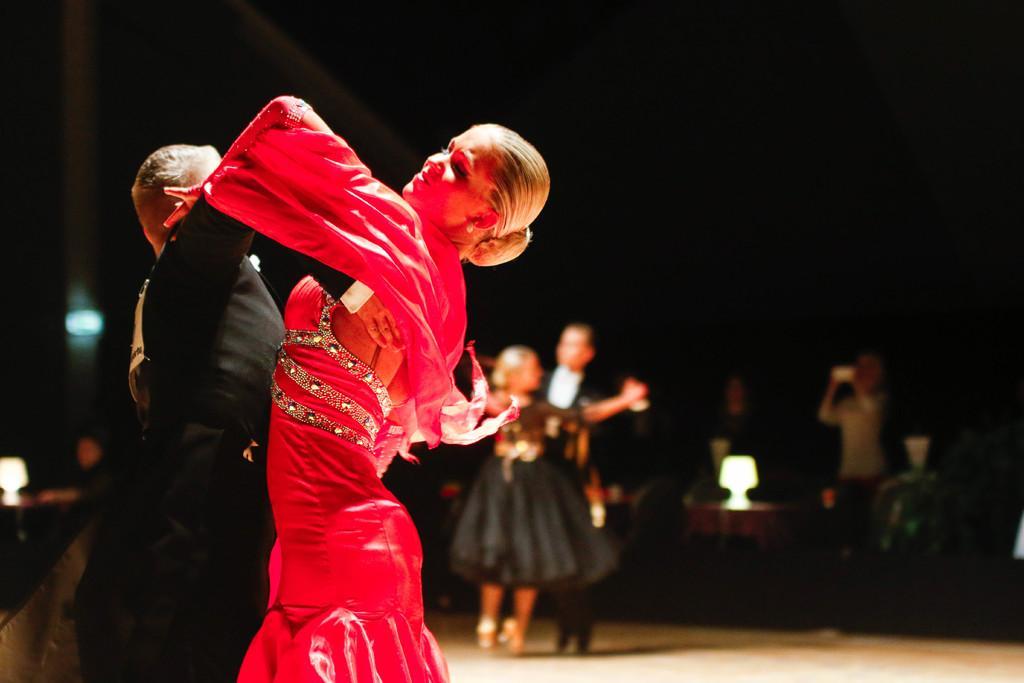Can you describe this image briefly? In this picture we can see there are four people dancing on the floor and another person is holding an object. Behind the people there is a dark background and some blurred objects. 